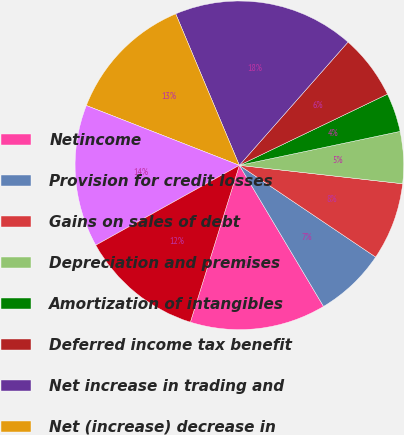<chart> <loc_0><loc_0><loc_500><loc_500><pie_chart><fcel>Netincome<fcel>Provision for credit losses<fcel>Gains on sales of debt<fcel>Depreciation and premises<fcel>Amortization of intangibles<fcel>Deferred income tax benefit<fcel>Net increase in trading and<fcel>Net (increase) decrease in<fcel>Net decrease in accrued<fcel>Other operating activities net<nl><fcel>13.38%<fcel>7.01%<fcel>7.64%<fcel>5.1%<fcel>3.82%<fcel>6.37%<fcel>17.83%<fcel>12.74%<fcel>14.01%<fcel>12.1%<nl></chart> 